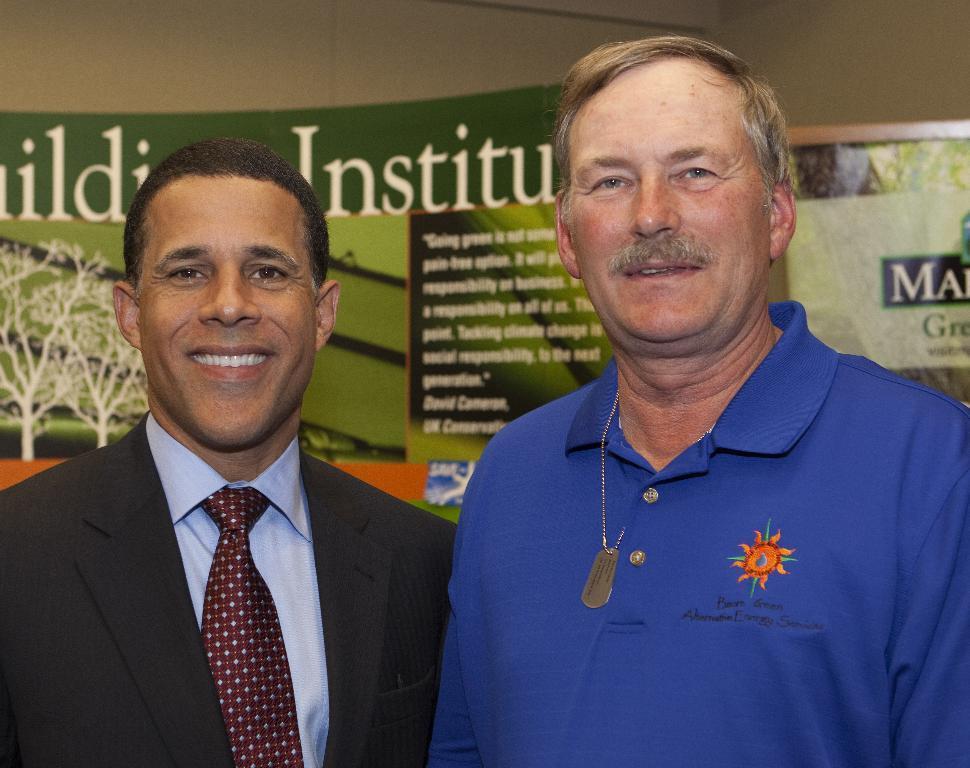Can you describe this image briefly? There are two men smiling. Background we can see banners and wall. 